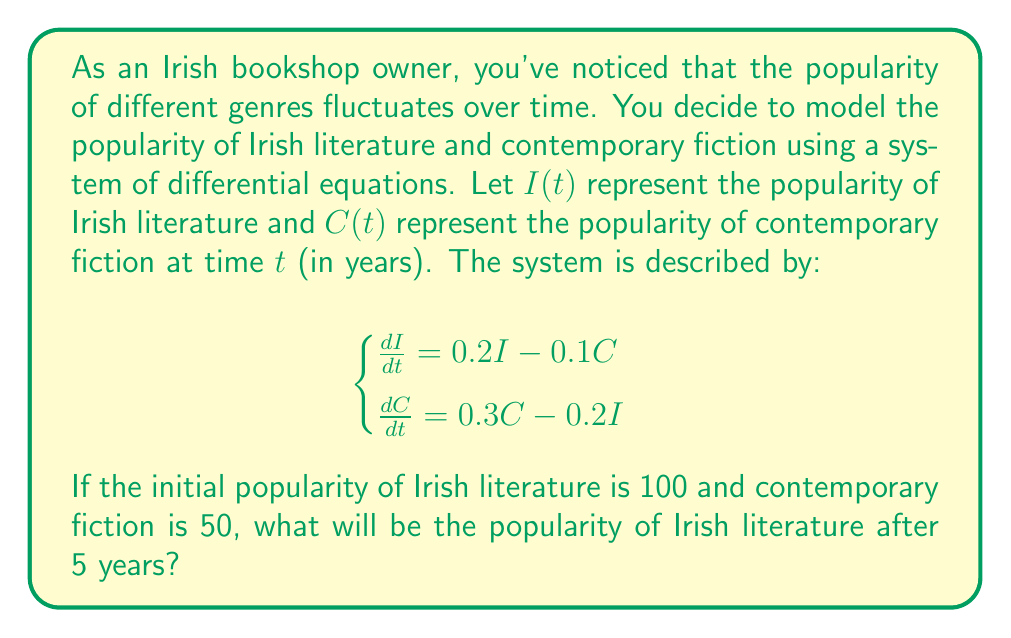Could you help me with this problem? To solve this system of differential equations, we'll use the eigenvalue method:

1) First, write the system in matrix form:
   $$\frac{d}{dt}\begin{bmatrix} I \\ C \end{bmatrix} = \begin{bmatrix} 0.2 & -0.1 \\ -0.2 & 0.3 \end{bmatrix}\begin{bmatrix} I \\ C \end{bmatrix}$$

2) Find the eigenvalues by solving $\det(A - \lambda I) = 0$:
   $$\det\begin{bmatrix} 0.2-\lambda & -0.1 \\ -0.2 & 0.3-\lambda \end{bmatrix} = 0$$
   $$(0.2-\lambda)(0.3-\lambda) - 0.02 = 0$$
   $$\lambda^2 - 0.5\lambda + 0.04 = 0$$
   $$\lambda = \frac{0.5 \pm \sqrt{0.25 - 0.16}}{2} = \frac{0.5 \pm 0.3}{2}$$
   $$\lambda_1 = 0.4, \lambda_2 = 0.1$$

3) Find the eigenvectors:
   For $\lambda_1 = 0.4$:
   $$\begin{bmatrix} -0.2 & -0.1 \\ -0.2 & -0.1 \end{bmatrix}\begin{bmatrix} v_1 \\ v_2 \end{bmatrix} = \begin{bmatrix} 0 \\ 0 \end{bmatrix}$$
   $v_1 = v_2$, so $\vec{v_1} = \begin{bmatrix} 1 \\ 1 \end{bmatrix}$

   For $\lambda_2 = 0.1$:
   $$\begin{bmatrix} 0.1 & -0.1 \\ -0.2 & 0.2 \end{bmatrix}\begin{bmatrix} v_1 \\ v_2 \end{bmatrix} = \begin{bmatrix} 0 \\ 0 \end{bmatrix}$$
   $v_1 = -v_2$, so $\vec{v_2} = \begin{bmatrix} 1 \\ -1 \end{bmatrix}$

4) The general solution is:
   $$\begin{bmatrix} I \\ C \end{bmatrix} = c_1e^{0.4t}\begin{bmatrix} 1 \\ 1 \end{bmatrix} + c_2e^{0.1t}\begin{bmatrix} 1 \\ -1 \end{bmatrix}$$

5) Use initial conditions to find $c_1$ and $c_2$:
   $$\begin{bmatrix} 100 \\ 50 \end{bmatrix} = c_1\begin{bmatrix} 1 \\ 1 \end{bmatrix} + c_2\begin{bmatrix} 1 \\ -1 \end{bmatrix}$$
   $$c_1 = 75, c_2 = 25$$

6) The solution for $I(t)$ is:
   $$I(t) = 75e^{0.4t} + 25e^{0.1t}$$

7) Evaluate $I(5)$:
   $$I(5) = 75e^{0.4(5)} + 25e^{0.1(5)} = 75e^2 + 25e^{0.5} \approx 280.34$$
Answer: The popularity of Irish literature after 5 years will be approximately 280.34. 